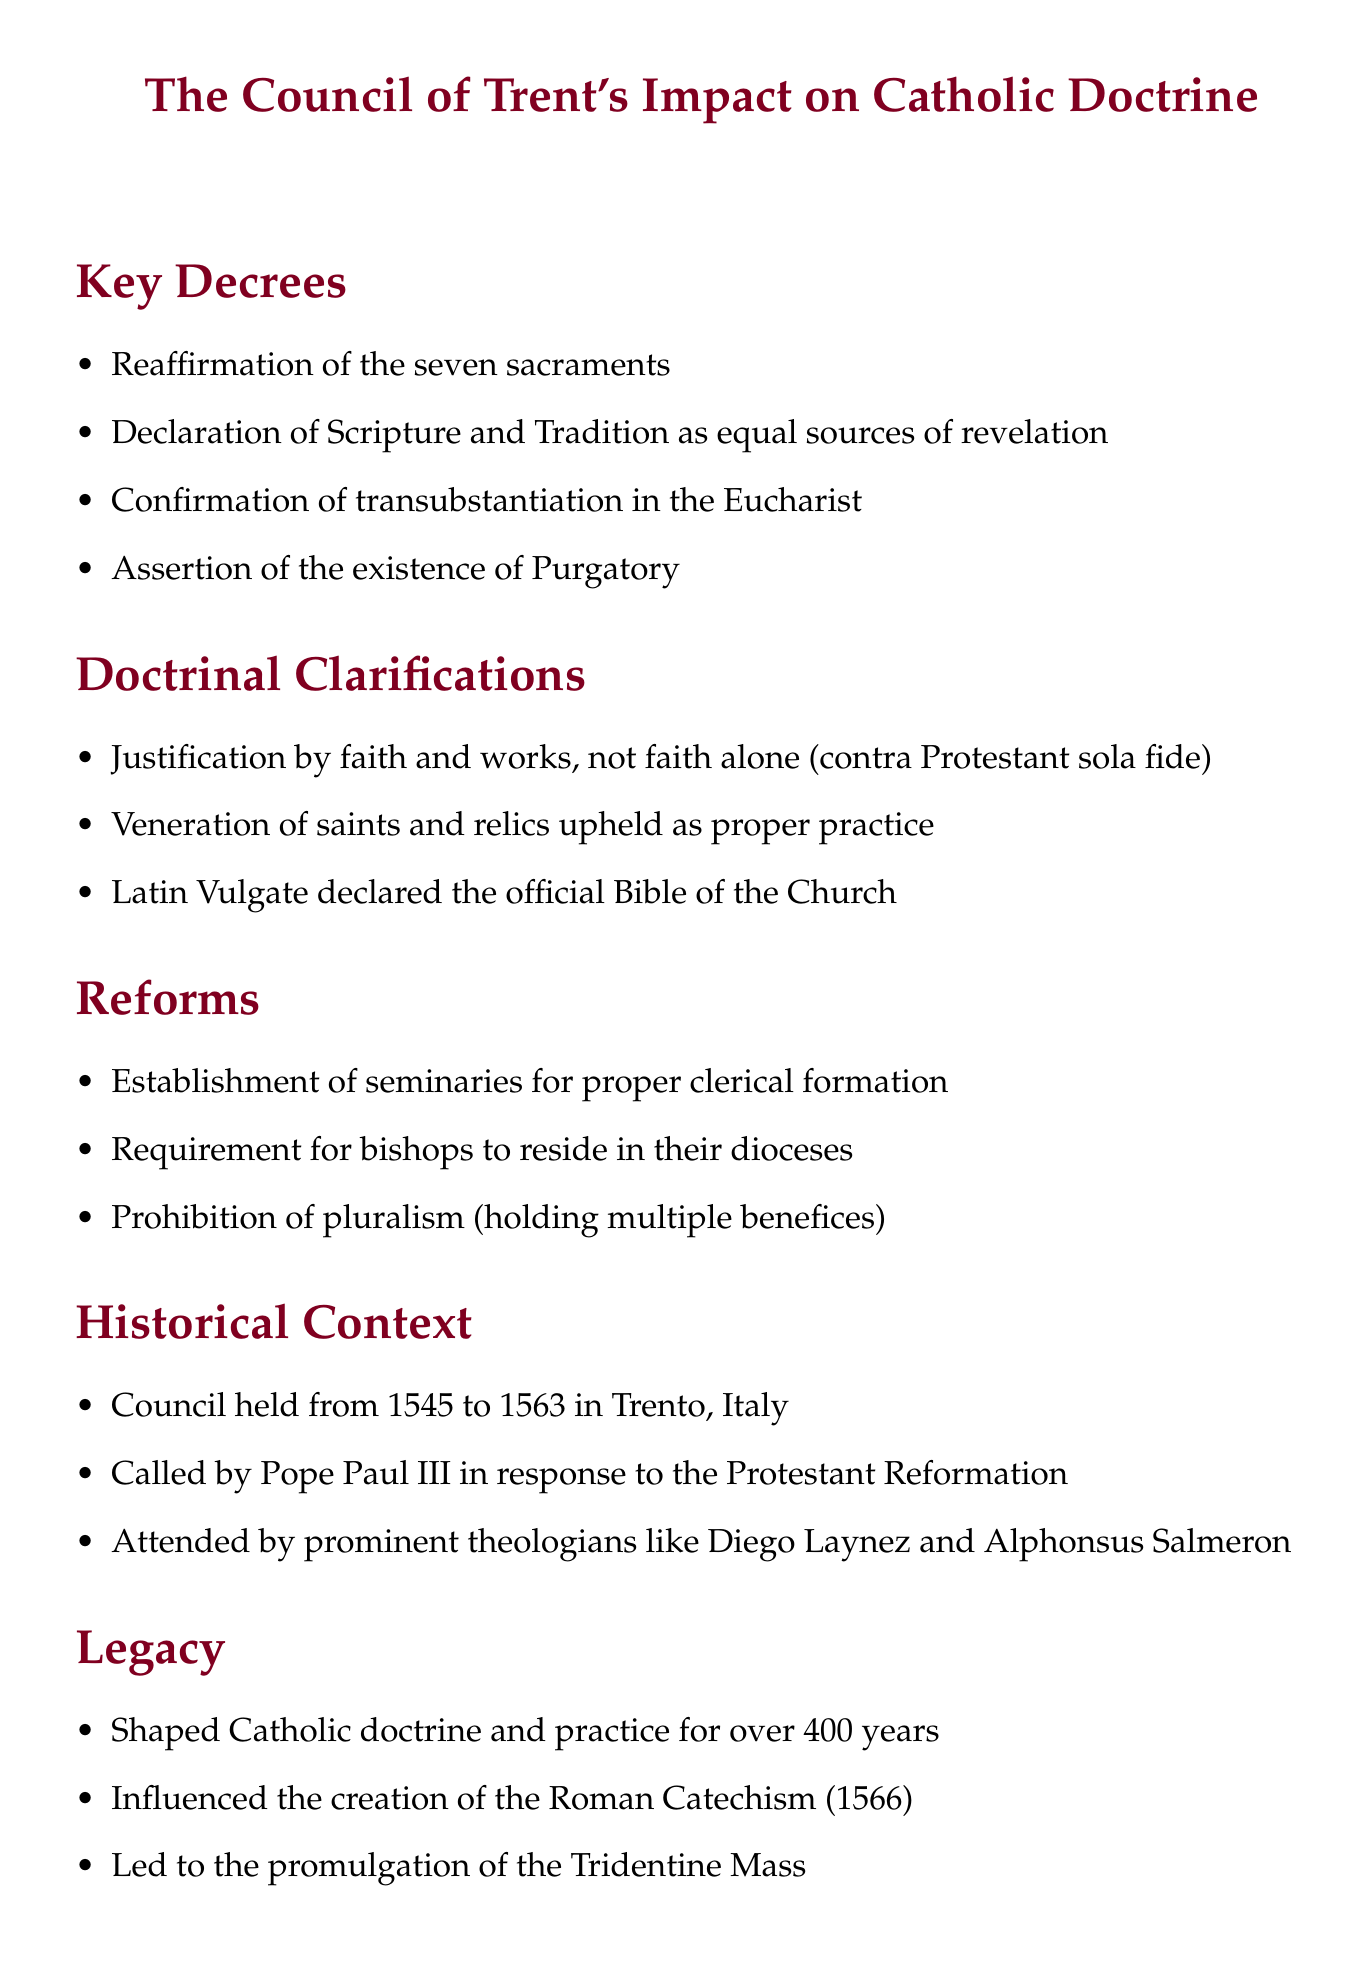What were the dates of the Council of Trent? The document states that the council was held from 1545 to 1563.
Answer: 1545 to 1563 Who called the Council of Trent? According to the document, Pope Paul III called the council in response to the Protestant Reformation.
Answer: Pope Paul III What is the official Bible of the Church declared by the Council? The Council declared the Latin Vulgate as the official Bible of the Church.
Answer: Latin Vulgate What significant theological doctrine regarding the Eucharist was confirmed? The confirmation of transubstantiation in the Eucharist is noted in the document.
Answer: Transubstantiation What reform was established regarding clerical formation? The document mentions the establishment of seminaries for proper clerical formation as a reform.
Answer: Establishment of seminaries Which practice regarding saints was upheld by the Council? The veneration of saints and relics was upheld as proper practice according to the document.
Answer: Veneration of saints and relics How many years did the Council of Trent influence Catholic doctrine? The document states it shaped Catholic doctrine and practice for over 400 years.
Answer: Over 400 years Name a prominent theologian who attended the Council of Trent. The document lists Diego Laynez and Alphonsus Salmeron as prominent theologians who attended.
Answer: Diego Laynez 